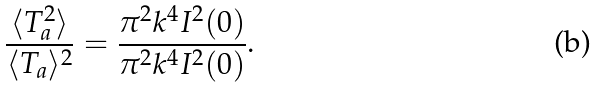<formula> <loc_0><loc_0><loc_500><loc_500>\frac { \langle T _ { a } ^ { 2 } \rangle } { \langle T _ { a } \rangle ^ { 2 } } = \frac { \pi ^ { 2 } k ^ { 4 } I ^ { 2 } ( 0 ) } { \pi ^ { 2 } k ^ { 4 } I ^ { 2 } ( 0 ) } .</formula> 